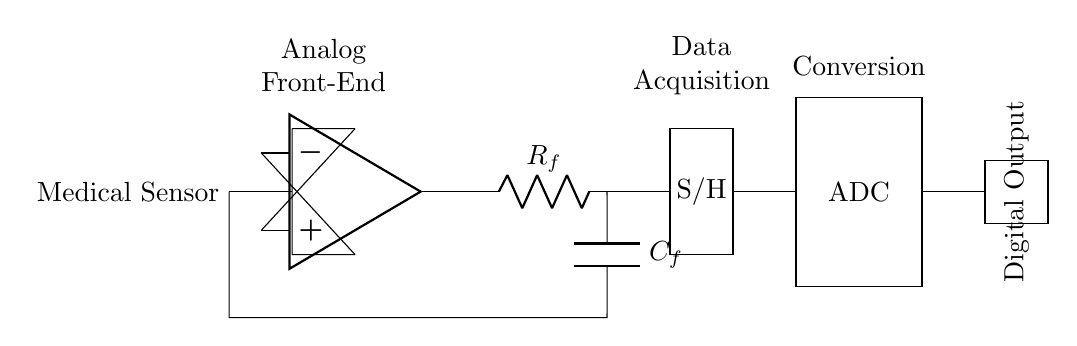What component is connected to the medical sensor? The medical sensor is connected to an operational amplifier (op amp), which amplifies the sensor's analog signal before further processing.
Answer: Operational amplifier What type of signal does the ADC convert? The Analog-to-Digital Converter (ADC) converts the analog signal coming from the Sample and Hold circuit into a digital output, allowing for digital processing and storage of the sensor data.
Answer: Analog What is the function of the low-pass filter in this circuit? The low-pass filter smooths out the output from the operational amplifier by attenuating high-frequency noise, thus helping to ensure a cleaner signal is sent to the Sample and Hold circuit.
Answer: Noise reduction How many main sections are in this circuit? The circuit consists of three main sections: the Analog Front-End (which includes the sensor and amplifier), the Data Acquisition (which includes the Sample and Hold), and the Conversion (which includes the ADC).
Answer: Three What does the abbreviation S/H stand for in this circuit? The abbreviation S/H stands for Sample and Hold, which is a circuit that samples the analog signal at a specific moment and holds that value for a certain period of time before conversion.
Answer: Sample and Hold What is the output of the ADC? The output of the ADC is the digital representation of the analog signal, which can be further processed or analyzed in digital form.
Answer: Digital Output What is the role of the resistor and capacitor connected in series? The resistor and capacitor together form a low-pass filter that limits the frequency range of the signal passed to the following stage, helping to reduce unwanted high-frequency components.
Answer: Low-pass filter 